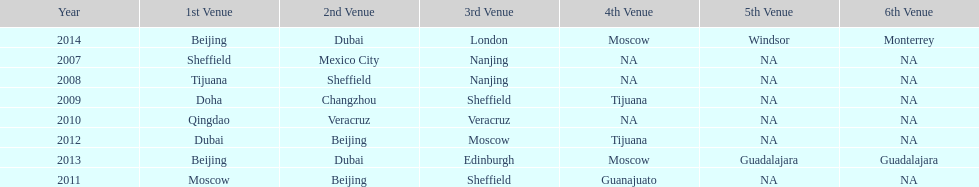In what year was the 3rd venue the same as 2011's 1st venue? 2012. 